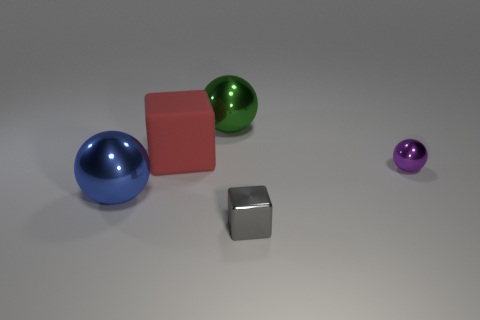Add 1 small purple things. How many objects exist? 6 Subtract all balls. How many objects are left? 2 Subtract all brown rubber blocks. Subtract all small gray objects. How many objects are left? 4 Add 1 large matte blocks. How many large matte blocks are left? 2 Add 4 matte cubes. How many matte cubes exist? 5 Subtract 0 gray cylinders. How many objects are left? 5 